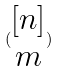Convert formula to latex. <formula><loc_0><loc_0><loc_500><loc_500>( \begin{matrix} [ n ] \\ m \end{matrix} )</formula> 